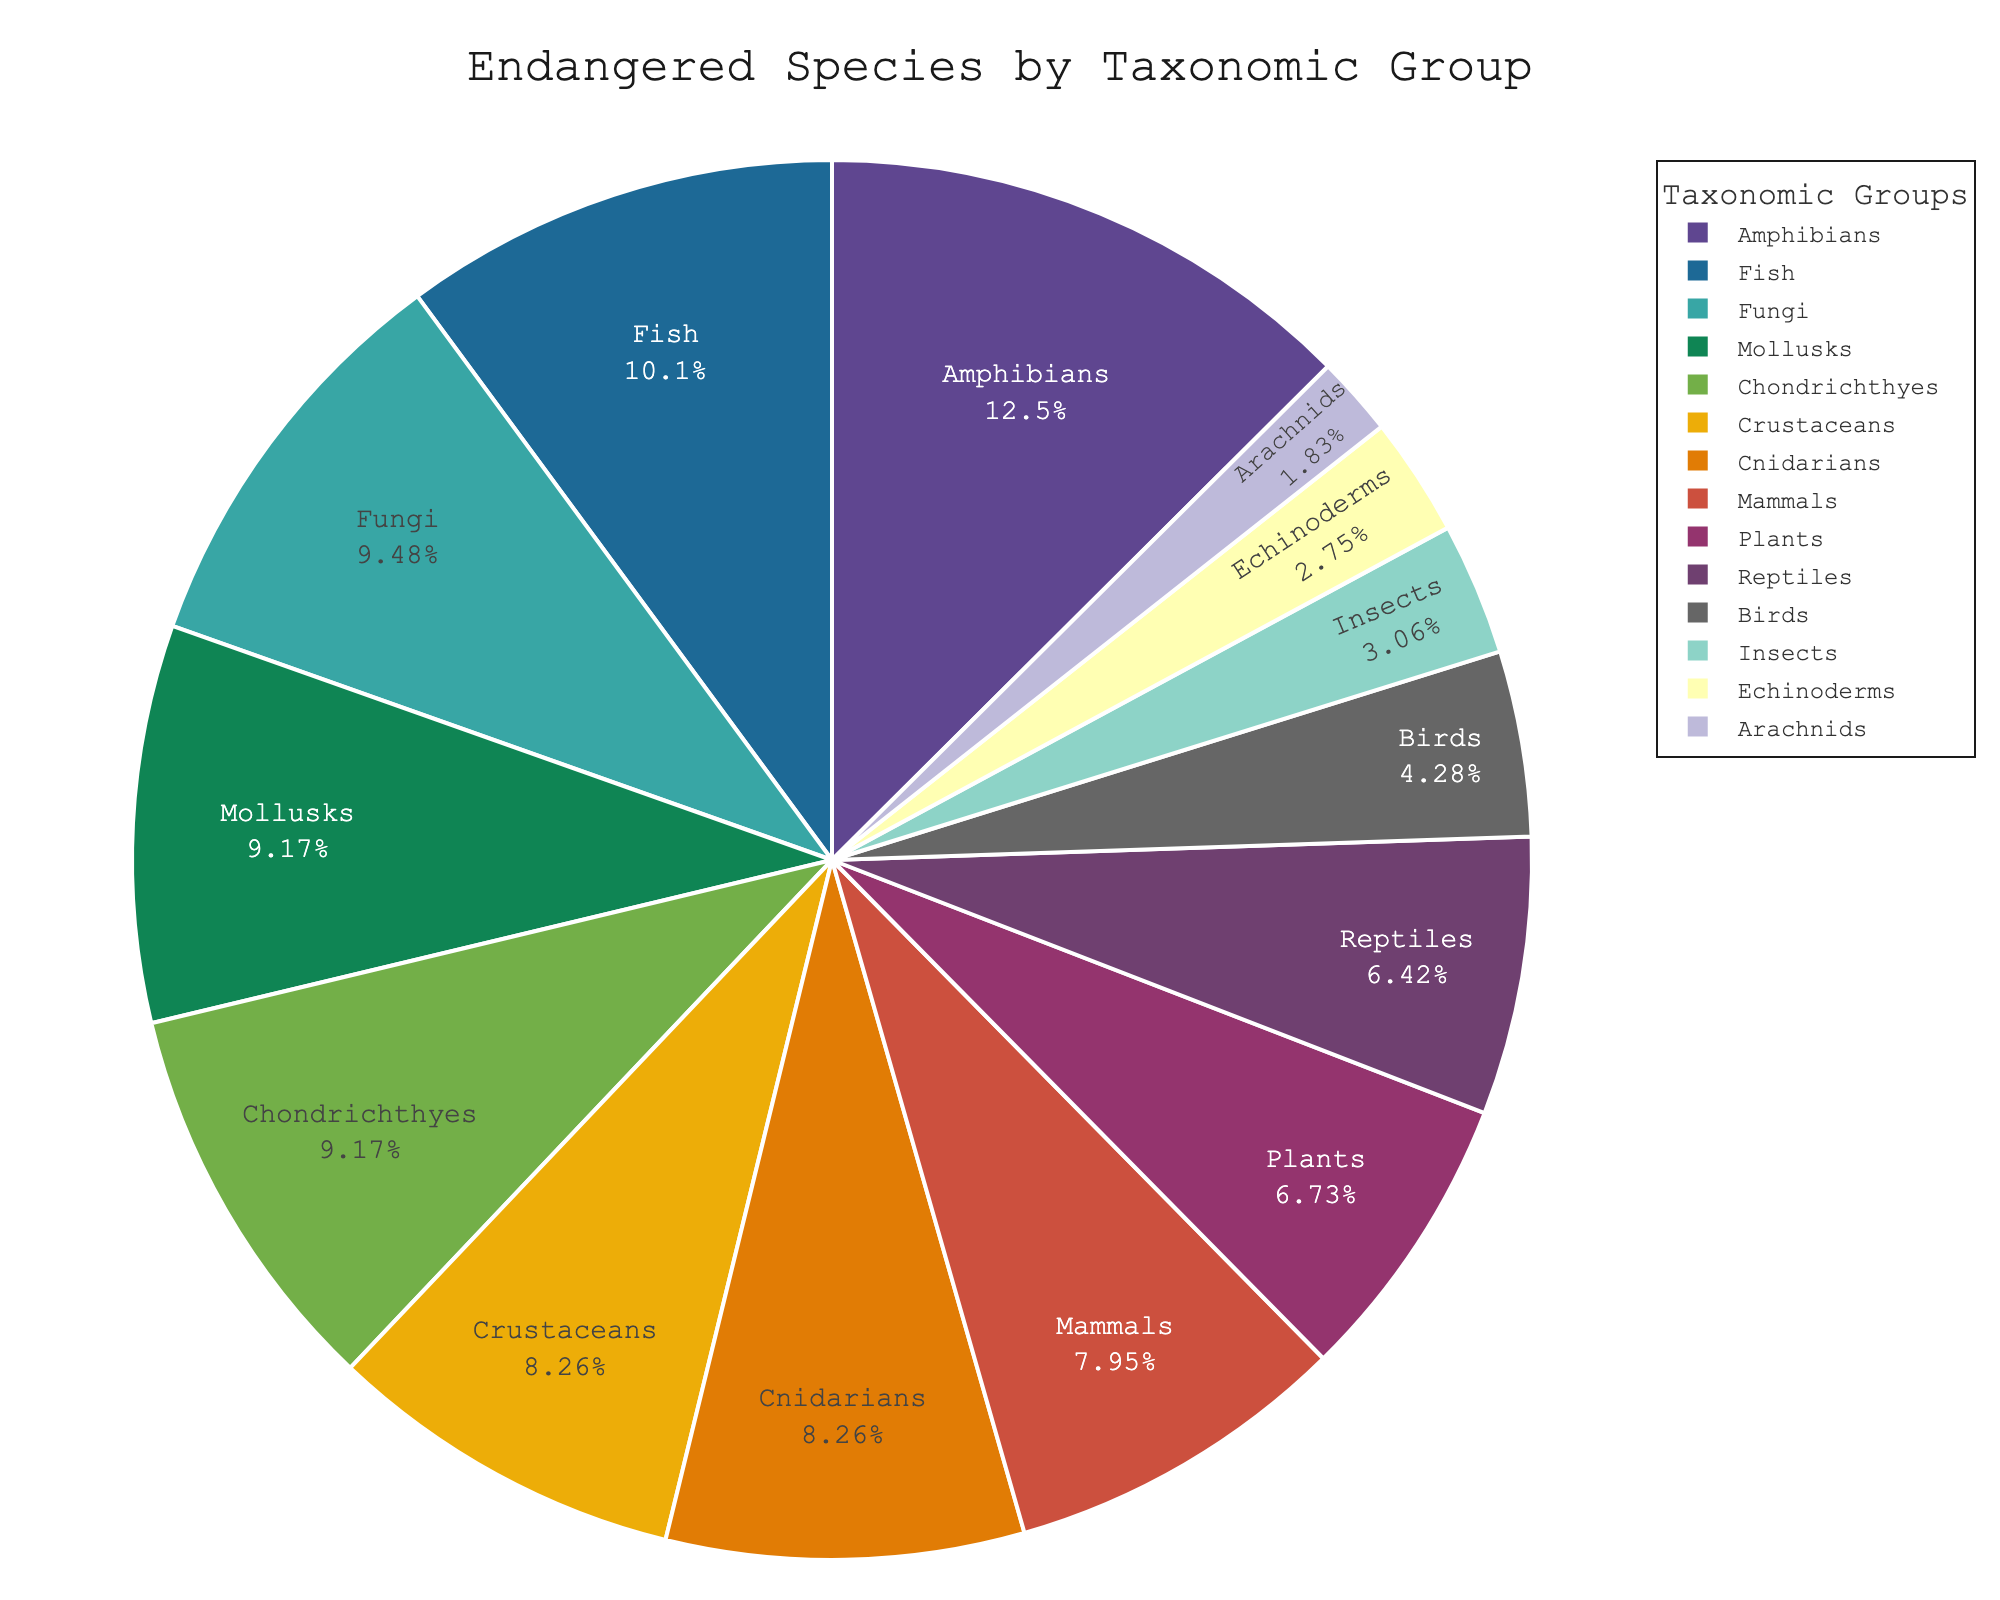Which taxonomic group has the highest percentage of endangered species? The group with the highest percentage of endangered species is identified by finding the segment with the largest value in the pie chart.
Answer: Amphibians What is the difference in the percentage of endangered species between mammals and birds? Locate the percentages for mammals (26%) and birds (14%) in the chart, then subtract the percentage of birds from mammals (26 - 14 = 12).
Answer: 12 Which taxonomic groups have an equal percentage of endangered species? Identify all segments in the pie chart that have the same percentage. The segments for Chondrichthyes and Mollusks both show 30%.
Answer: Chondrichthyes and Mollusks How many groups have a percentage of endangered species greater than 25%? Count the segments that have a value greater than 25%. These groups are mammals, reptiles, fish, mollusks, crustaceans, fungi, and cnidarians, which totals to 7.
Answer: 7 What is the sum of the percentages of endangered species for mammals, birds, and reptiles? Add the percentages for mammals (26%), birds (14%), and reptiles (21%) together: 26 + 14 + 21 = 61.
Answer: 61 Which taxonomic group has a smaller percentage of endangered species compared to fish but larger than insects? Compare the percentage values of fish (33%) and insects (10%) to find a group that fits within this range. Mollusks (30%) fits this criteria.
Answer: Mollusks Which taxonomic group has the smallest percentage of endangered species? Identify the segment with the smallest value in the pie chart. The smallest value is for Arachnids, which is 6%.
Answer: Arachnids What's the median value of the percentages of endangered species across all taxonomic groups? List all the percentages in order: 6, 9, 10, 14, 21, 22, 26, 27, 27, 30, 30, 31, 33, 41. The median value is the middle number, or the average of the two middle numbers if the list has an even length. Here, the middle numbers are 26 and 27, and their average is (26 + 27) / 2 = 26.5.
Answer: 26.5 How many groups have a percentage of endangered species below 20%? Count the segments that have a value below 20%. These groups are birds, insects, echinoderms, and arachnids, which totals to 4.
Answer: 4 